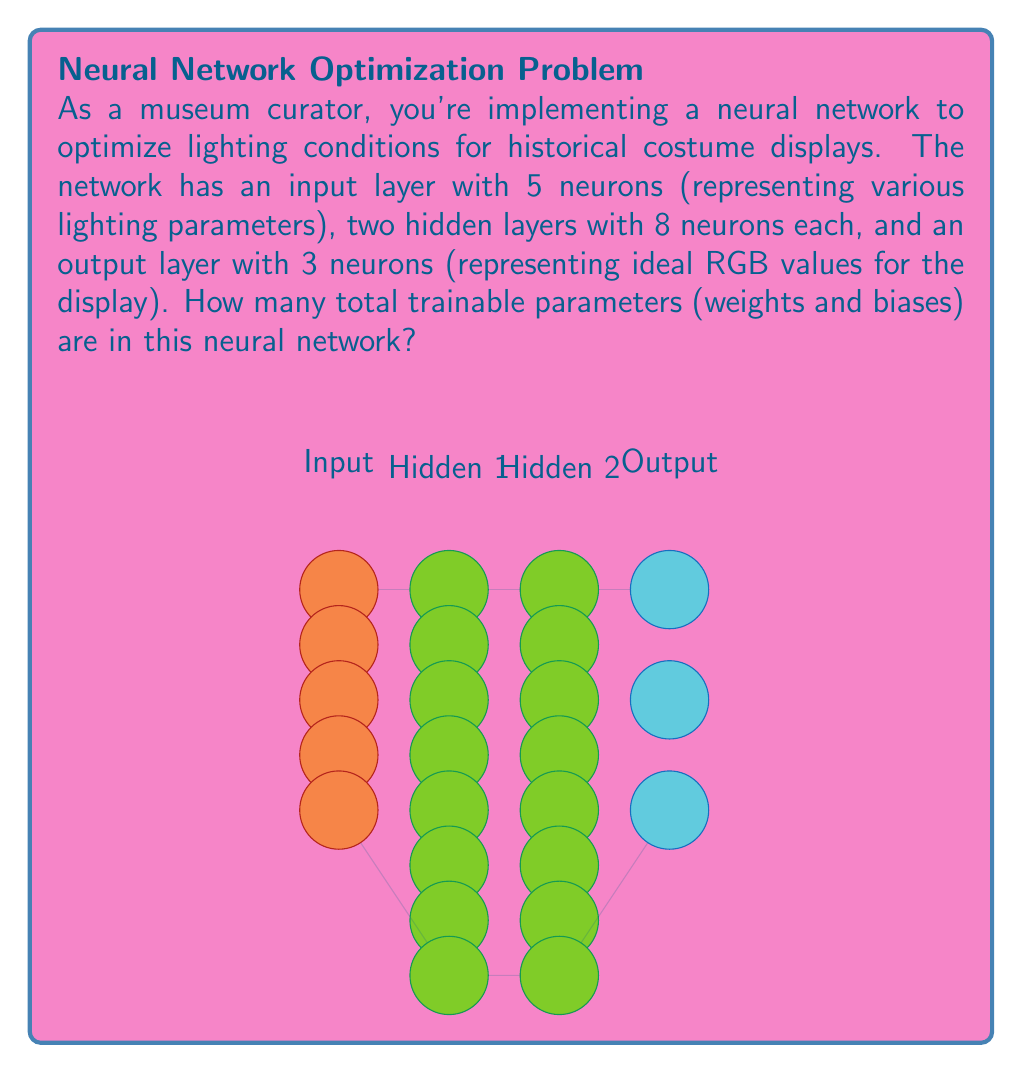Can you solve this math problem? Let's break this down step-by-step:

1) First, let's count the weights:
   - Between input and first hidden layer: $5 \times 8 = 40$
   - Between first and second hidden layer: $8 \times 8 = 64$
   - Between second hidden layer and output: $8 \times 3 = 24$

2) Now, let's count the biases:
   - First hidden layer: 8
   - Second hidden layer: 8
   - Output layer: 3

3) Total number of weights:
   $$ 40 + 64 + 24 = 128 $$

4) Total number of biases:
   $$ 8 + 8 + 3 = 19 $$

5) Total trainable parameters:
   $$ 128 + 19 = 147 $$

Therefore, the neural network has 147 trainable parameters in total.
Answer: 147 